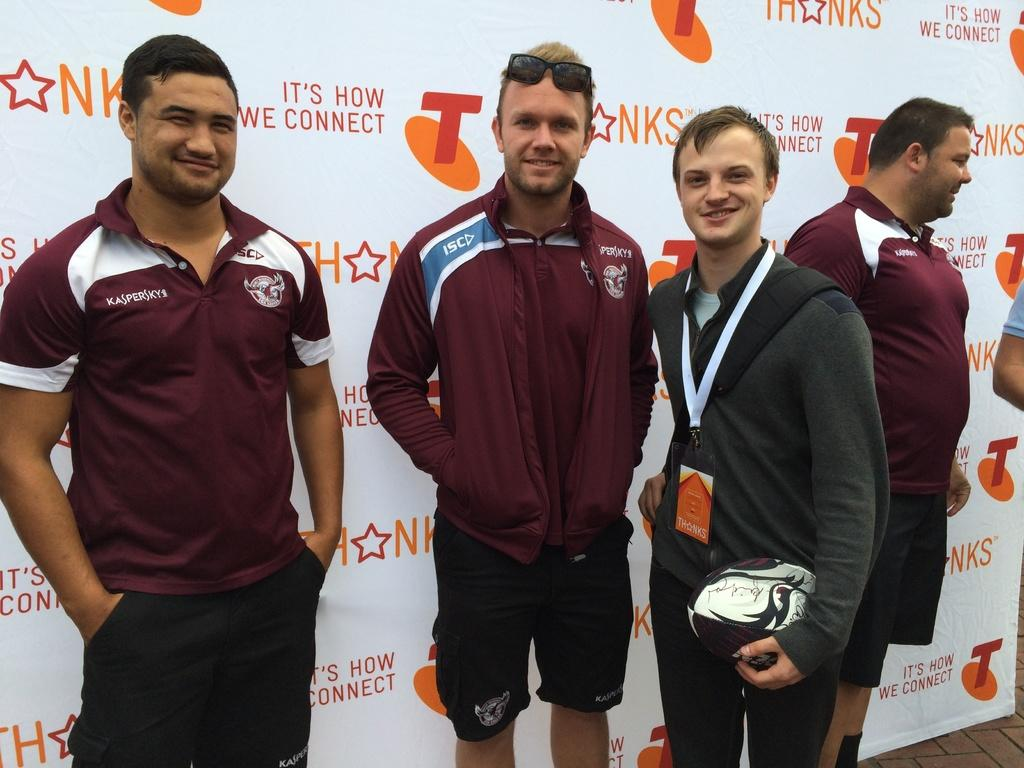<image>
Create a compact narrative representing the image presented. The people are standing in front of a panner that says NKS. 